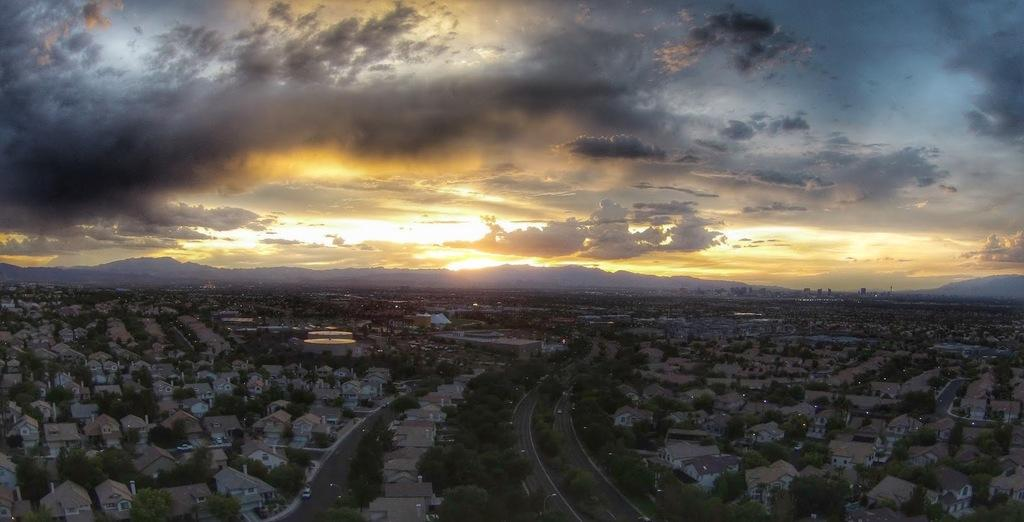What type of view is shown in the image? The image is an aerial view. What can be seen in the image from this perspective? There are many buildings, trees, roads, and hills visible in the image. What is visible in the background of the image? The sky is visible in the image. What type of hands can be seen holding chairs in the image? There are no hands or chairs present in the image; it is an aerial view of a landscape with buildings, trees, roads, hills, and the sky. What type of oatmeal is being served in the image? There is no oatmeal or serving activity present in the image. 